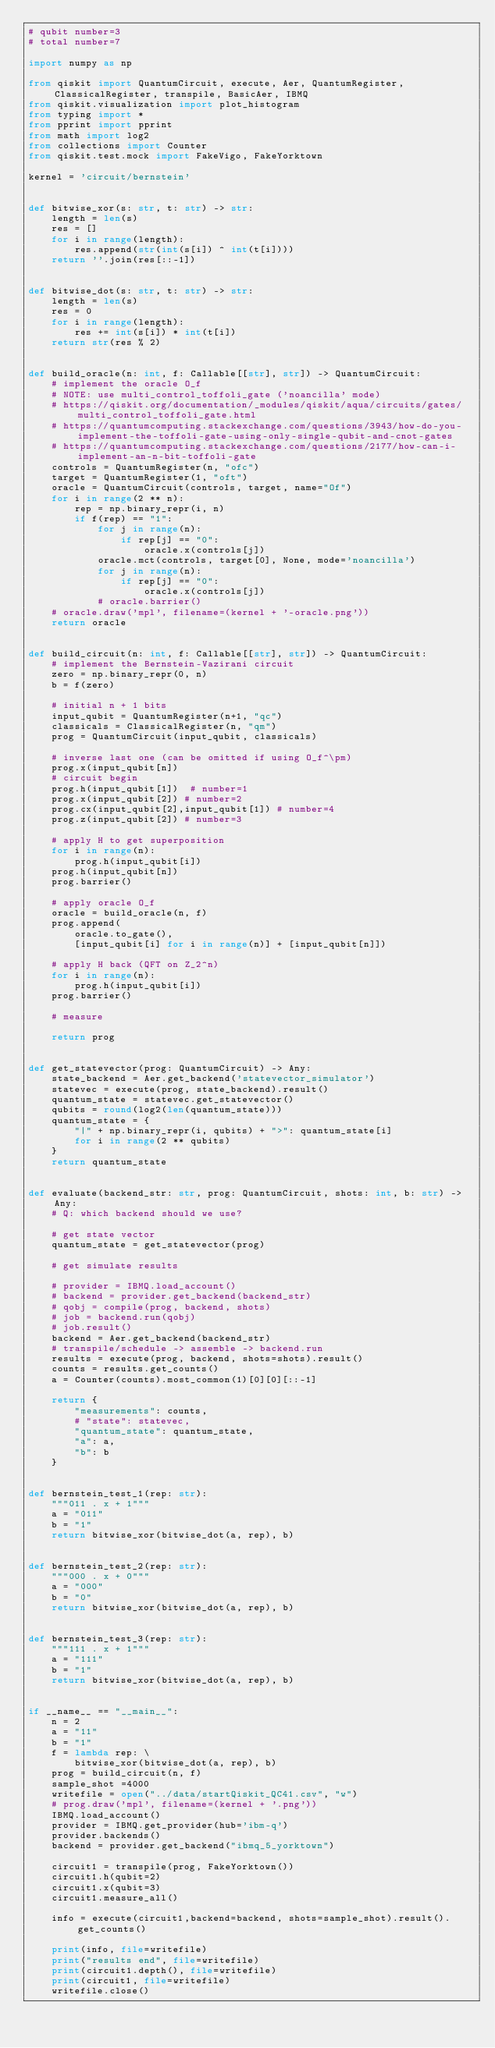<code> <loc_0><loc_0><loc_500><loc_500><_Python_># qubit number=3
# total number=7

import numpy as np

from qiskit import QuantumCircuit, execute, Aer, QuantumRegister, ClassicalRegister, transpile, BasicAer, IBMQ
from qiskit.visualization import plot_histogram
from typing import *
from pprint import pprint
from math import log2
from collections import Counter
from qiskit.test.mock import FakeVigo, FakeYorktown

kernel = 'circuit/bernstein'


def bitwise_xor(s: str, t: str) -> str:
    length = len(s)
    res = []
    for i in range(length):
        res.append(str(int(s[i]) ^ int(t[i])))
    return ''.join(res[::-1])


def bitwise_dot(s: str, t: str) -> str:
    length = len(s)
    res = 0
    for i in range(length):
        res += int(s[i]) * int(t[i])
    return str(res % 2)


def build_oracle(n: int, f: Callable[[str], str]) -> QuantumCircuit:
    # implement the oracle O_f
    # NOTE: use multi_control_toffoli_gate ('noancilla' mode)
    # https://qiskit.org/documentation/_modules/qiskit/aqua/circuits/gates/multi_control_toffoli_gate.html
    # https://quantumcomputing.stackexchange.com/questions/3943/how-do-you-implement-the-toffoli-gate-using-only-single-qubit-and-cnot-gates
    # https://quantumcomputing.stackexchange.com/questions/2177/how-can-i-implement-an-n-bit-toffoli-gate
    controls = QuantumRegister(n, "ofc")
    target = QuantumRegister(1, "oft")
    oracle = QuantumCircuit(controls, target, name="Of")
    for i in range(2 ** n):
        rep = np.binary_repr(i, n)
        if f(rep) == "1":
            for j in range(n):
                if rep[j] == "0":
                    oracle.x(controls[j])
            oracle.mct(controls, target[0], None, mode='noancilla')
            for j in range(n):
                if rep[j] == "0":
                    oracle.x(controls[j])
            # oracle.barrier()
    # oracle.draw('mpl', filename=(kernel + '-oracle.png'))
    return oracle


def build_circuit(n: int, f: Callable[[str], str]) -> QuantumCircuit:
    # implement the Bernstein-Vazirani circuit
    zero = np.binary_repr(0, n)
    b = f(zero)

    # initial n + 1 bits
    input_qubit = QuantumRegister(n+1, "qc")
    classicals = ClassicalRegister(n, "qm")
    prog = QuantumCircuit(input_qubit, classicals)

    # inverse last one (can be omitted if using O_f^\pm)
    prog.x(input_qubit[n])
    # circuit begin
    prog.h(input_qubit[1])  # number=1
    prog.x(input_qubit[2]) # number=2
    prog.cx(input_qubit[2],input_qubit[1]) # number=4
    prog.z(input_qubit[2]) # number=3

    # apply H to get superposition
    for i in range(n):
        prog.h(input_qubit[i])
    prog.h(input_qubit[n])
    prog.barrier()

    # apply oracle O_f
    oracle = build_oracle(n, f)
    prog.append(
        oracle.to_gate(),
        [input_qubit[i] for i in range(n)] + [input_qubit[n]])

    # apply H back (QFT on Z_2^n)
    for i in range(n):
        prog.h(input_qubit[i])
    prog.barrier()

    # measure

    return prog


def get_statevector(prog: QuantumCircuit) -> Any:
    state_backend = Aer.get_backend('statevector_simulator')
    statevec = execute(prog, state_backend).result()
    quantum_state = statevec.get_statevector()
    qubits = round(log2(len(quantum_state)))
    quantum_state = {
        "|" + np.binary_repr(i, qubits) + ">": quantum_state[i]
        for i in range(2 ** qubits)
    }
    return quantum_state


def evaluate(backend_str: str, prog: QuantumCircuit, shots: int, b: str) -> Any:
    # Q: which backend should we use?

    # get state vector
    quantum_state = get_statevector(prog)

    # get simulate results

    # provider = IBMQ.load_account()
    # backend = provider.get_backend(backend_str)
    # qobj = compile(prog, backend, shots)
    # job = backend.run(qobj)
    # job.result()
    backend = Aer.get_backend(backend_str)
    # transpile/schedule -> assemble -> backend.run
    results = execute(prog, backend, shots=shots).result()
    counts = results.get_counts()
    a = Counter(counts).most_common(1)[0][0][::-1]

    return {
        "measurements": counts,
        # "state": statevec,
        "quantum_state": quantum_state,
        "a": a,
        "b": b
    }


def bernstein_test_1(rep: str):
    """011 . x + 1"""
    a = "011"
    b = "1"
    return bitwise_xor(bitwise_dot(a, rep), b)


def bernstein_test_2(rep: str):
    """000 . x + 0"""
    a = "000"
    b = "0"
    return bitwise_xor(bitwise_dot(a, rep), b)


def bernstein_test_3(rep: str):
    """111 . x + 1"""
    a = "111"
    b = "1"
    return bitwise_xor(bitwise_dot(a, rep), b)


if __name__ == "__main__":
    n = 2
    a = "11"
    b = "1"
    f = lambda rep: \
        bitwise_xor(bitwise_dot(a, rep), b)
    prog = build_circuit(n, f)
    sample_shot =4000
    writefile = open("../data/startQiskit_QC41.csv", "w")
    # prog.draw('mpl', filename=(kernel + '.png'))
    IBMQ.load_account() 
    provider = IBMQ.get_provider(hub='ibm-q') 
    provider.backends()
    backend = provider.get_backend("ibmq_5_yorktown")

    circuit1 = transpile(prog, FakeYorktown())
    circuit1.h(qubit=2)
    circuit1.x(qubit=3)
    circuit1.measure_all()

    info = execute(circuit1,backend=backend, shots=sample_shot).result().get_counts()

    print(info, file=writefile)
    print("results end", file=writefile)
    print(circuit1.depth(), file=writefile)
    print(circuit1, file=writefile)
    writefile.close()
</code> 